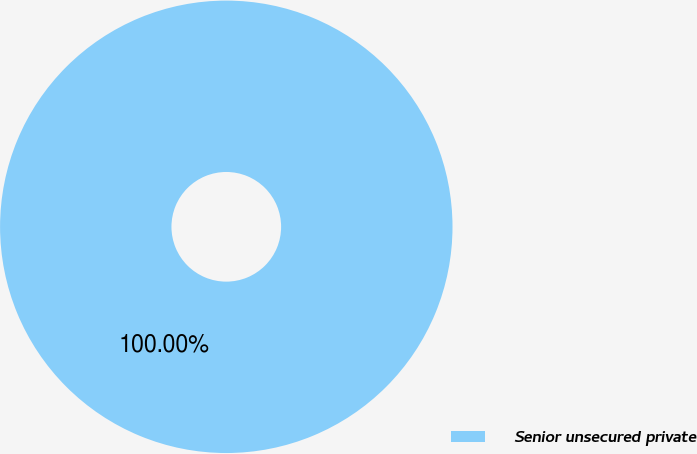<chart> <loc_0><loc_0><loc_500><loc_500><pie_chart><fcel>Senior unsecured private<nl><fcel>100.0%<nl></chart> 